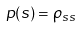<formula> <loc_0><loc_0><loc_500><loc_500>p ( s ) = \rho _ { s s }</formula> 